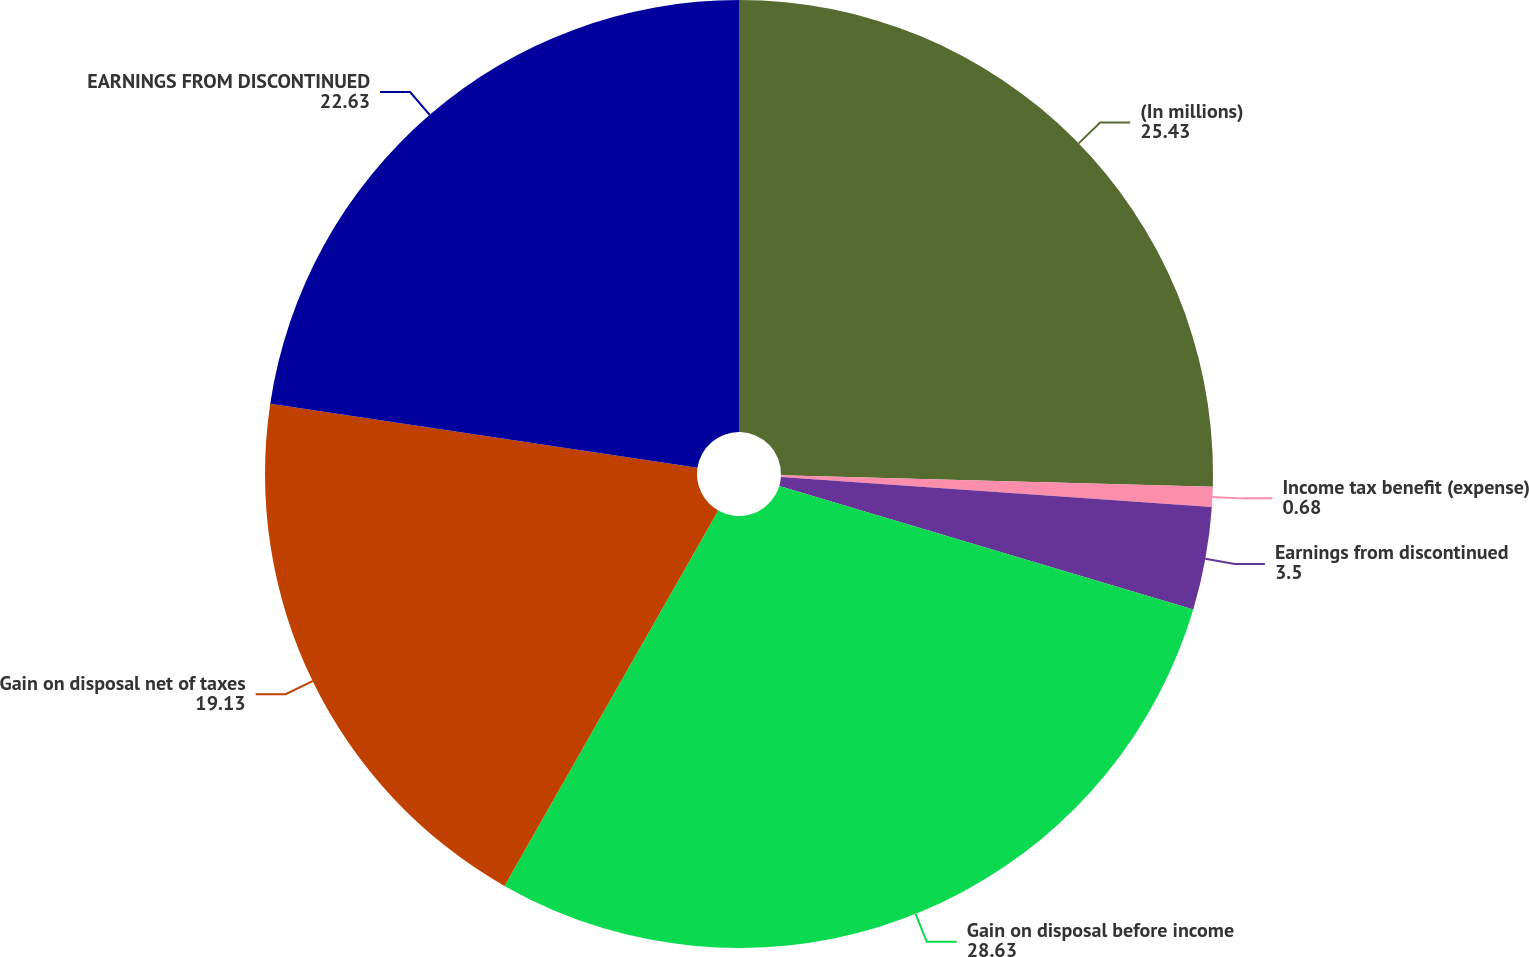<chart> <loc_0><loc_0><loc_500><loc_500><pie_chart><fcel>(In millions)<fcel>Income tax benefit (expense)<fcel>Earnings from discontinued<fcel>Gain on disposal before income<fcel>Gain on disposal net of taxes<fcel>EARNINGS FROM DISCONTINUED<nl><fcel>25.43%<fcel>0.68%<fcel>3.5%<fcel>28.63%<fcel>19.13%<fcel>22.63%<nl></chart> 